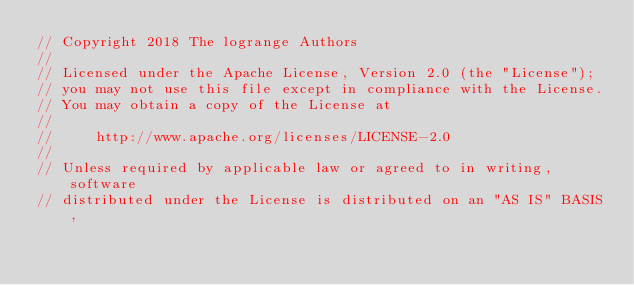Convert code to text. <code><loc_0><loc_0><loc_500><loc_500><_Go_>// Copyright 2018 The logrange Authors
//
// Licensed under the Apache License, Version 2.0 (the "License");
// you may not use this file except in compliance with the License.
// You may obtain a copy of the License at
//
//     http://www.apache.org/licenses/LICENSE-2.0
//
// Unless required by applicable law or agreed to in writing, software
// distributed under the License is distributed on an "AS IS" BASIS,</code> 